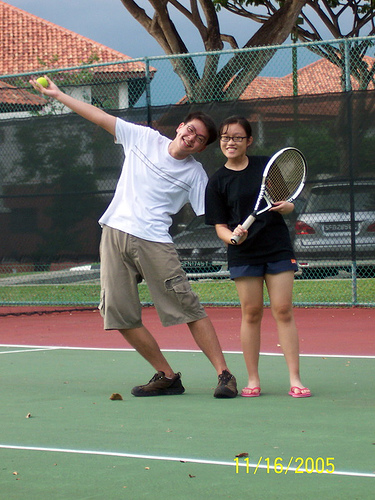Identify the text displayed in this image. 11 16 2005 